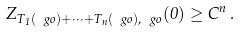Convert formula to latex. <formula><loc_0><loc_0><loc_500><loc_500>Z _ { T _ { 1 } ( \ g o ) + \dots + T _ { n } ( \ g o ) , \ g o } ( 0 ) \geq C ^ { n } \, .</formula> 